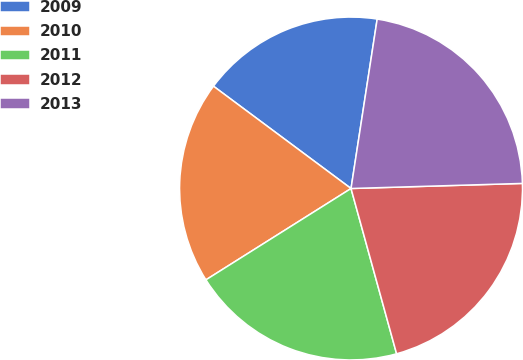Convert chart. <chart><loc_0><loc_0><loc_500><loc_500><pie_chart><fcel>2009<fcel>2010<fcel>2011<fcel>2012<fcel>2013<nl><fcel>17.26%<fcel>19.12%<fcel>20.34%<fcel>21.19%<fcel>22.09%<nl></chart> 